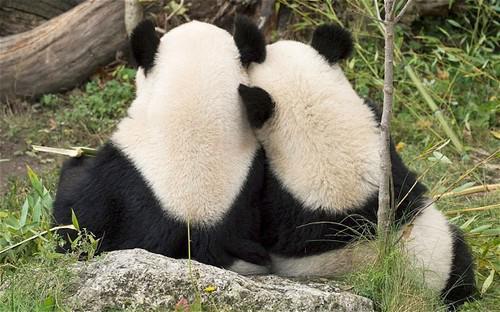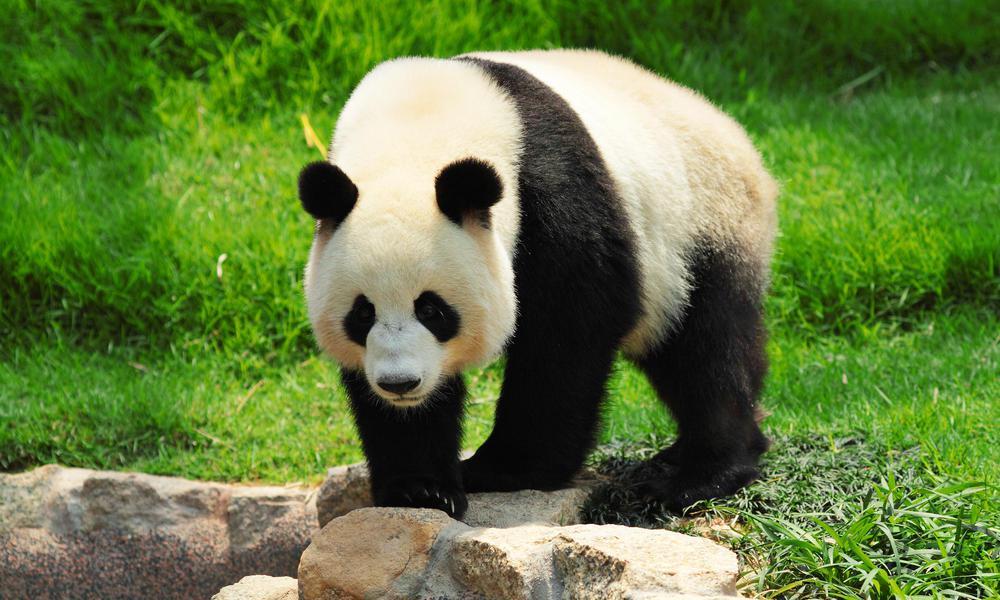The first image is the image on the left, the second image is the image on the right. Given the left and right images, does the statement "One image shows a pair of pandas side-by-side in similar poses, and the other features just one panda." hold true? Answer yes or no. Yes. The first image is the image on the left, the second image is the image on the right. Evaluate the accuracy of this statement regarding the images: "One giant panda is resting its chin on a log.". Is it true? Answer yes or no. No. 